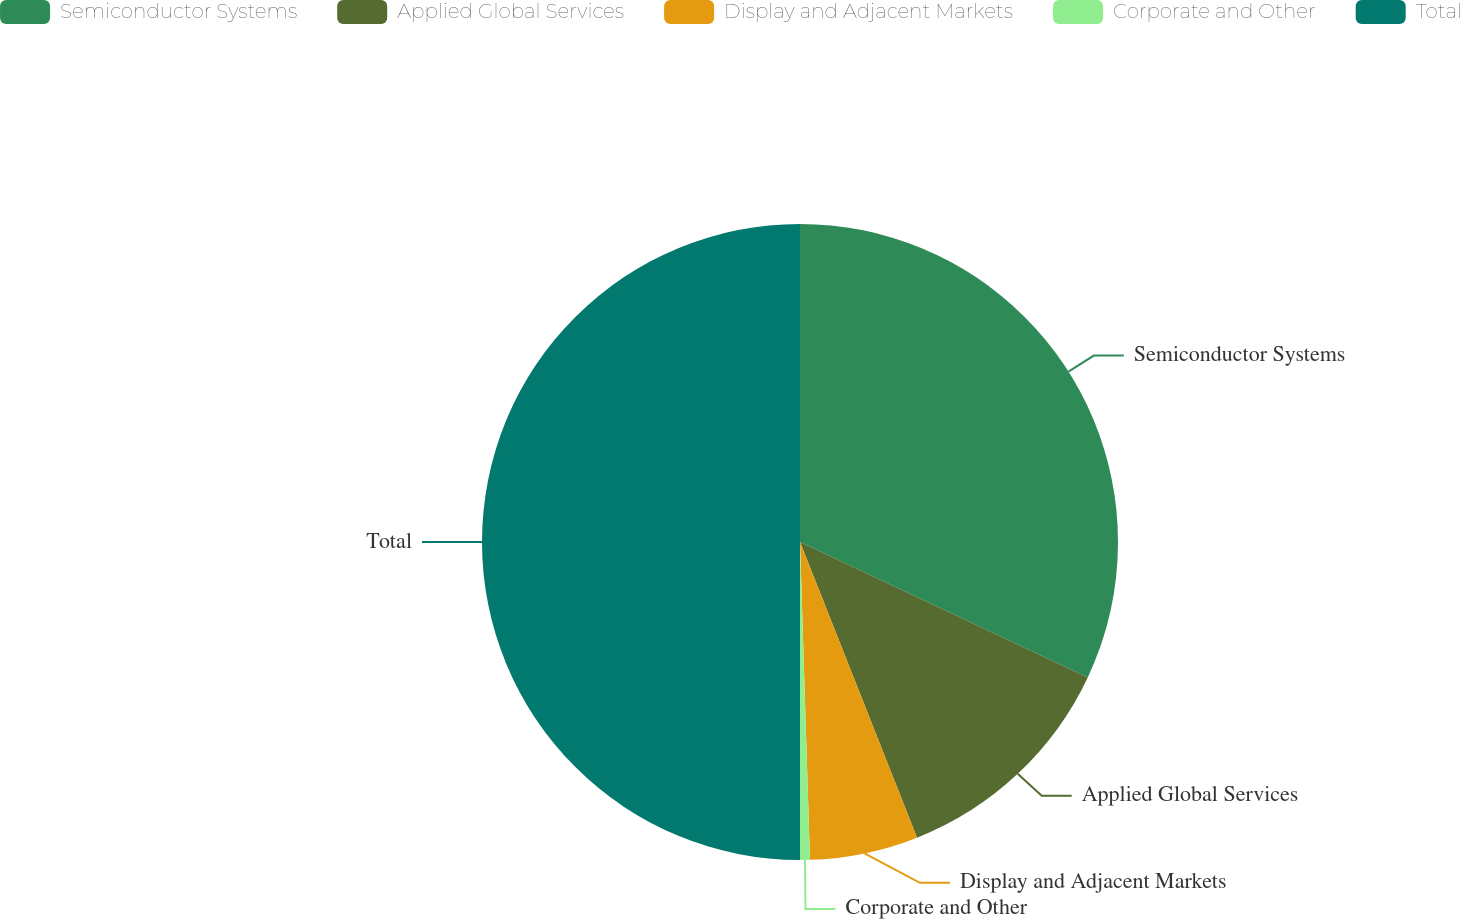<chart> <loc_0><loc_0><loc_500><loc_500><pie_chart><fcel>Semiconductor Systems<fcel>Applied Global Services<fcel>Display and Adjacent Markets<fcel>Corporate and Other<fcel>Total<nl><fcel>32.0%<fcel>12.0%<fcel>5.5%<fcel>0.5%<fcel>50.0%<nl></chart> 